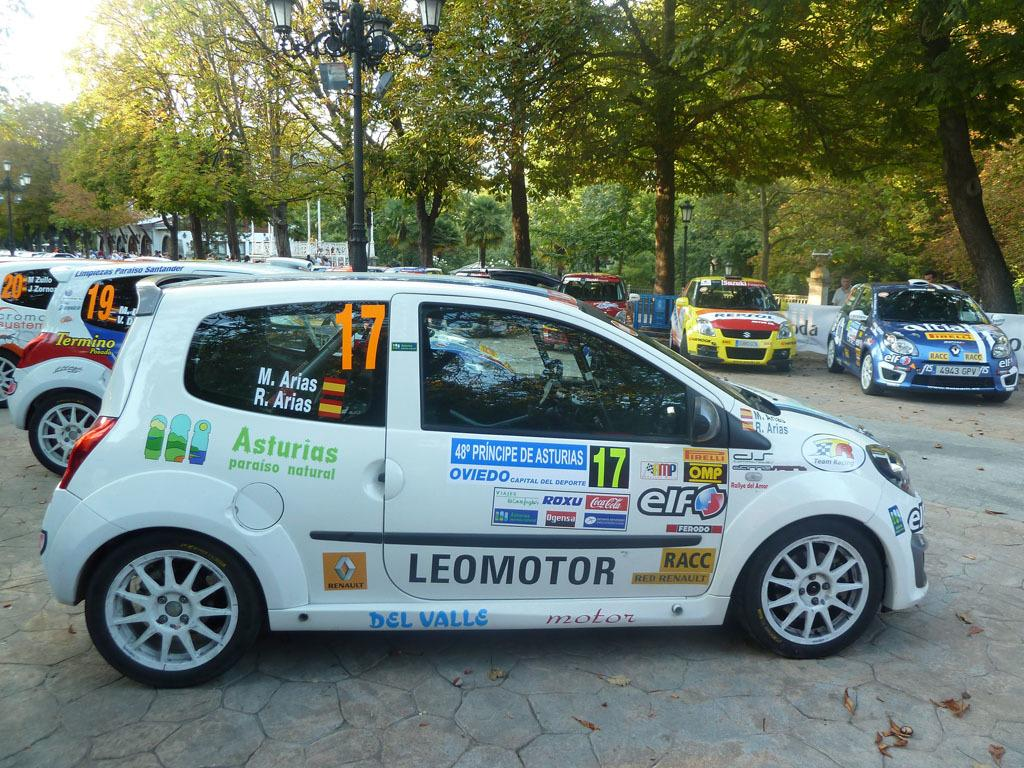What is the main subject of the image? The main subject of the image is many cars. Are there any additional features on the cars? Yes, there are posters on some of the cars. What can be seen in the background of the image? There are many trees and street light poles in the background of the image. How many cakes are being used to decorate the cars in the image? There are no cakes present in the image; it features cars with posters. What type of pain is being experienced by the sock in the image? There is no sock present in the image, so it is not possible to determine if it is experiencing any pain. 